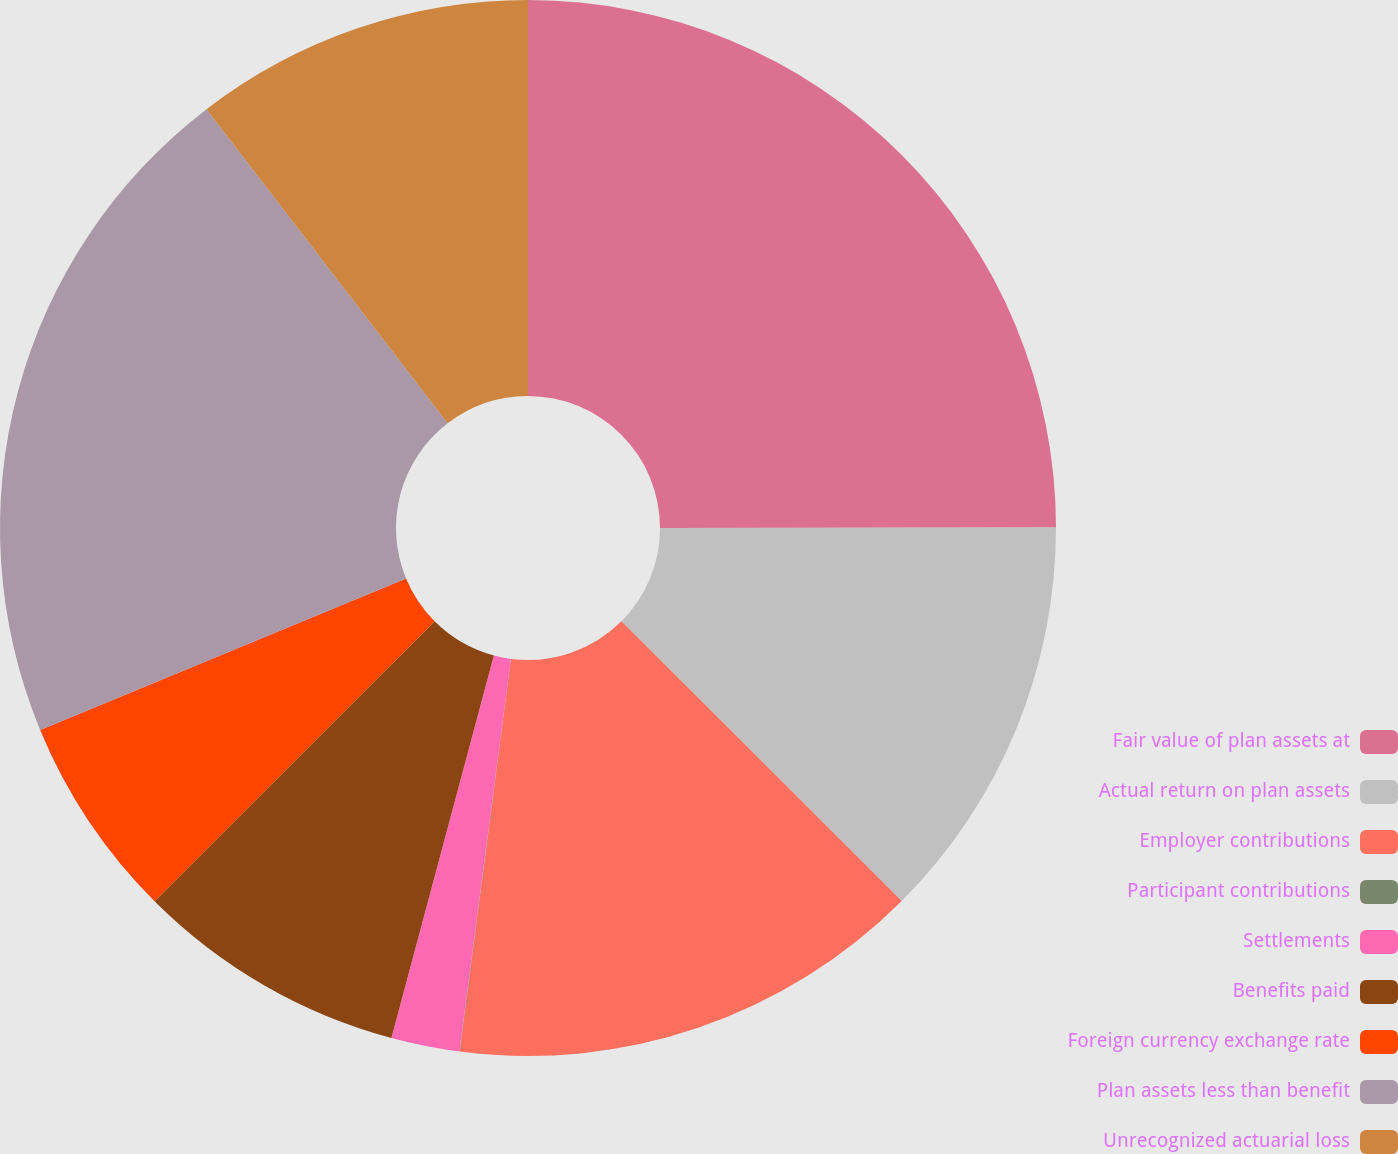Convert chart. <chart><loc_0><loc_0><loc_500><loc_500><pie_chart><fcel>Fair value of plan assets at<fcel>Actual return on plan assets<fcel>Employer contributions<fcel>Participant contributions<fcel>Settlements<fcel>Benefits paid<fcel>Foreign currency exchange rate<fcel>Plan assets less than benefit<fcel>Unrecognized actuarial loss<nl><fcel>24.99%<fcel>12.5%<fcel>14.58%<fcel>0.01%<fcel>2.09%<fcel>8.34%<fcel>6.25%<fcel>20.83%<fcel>10.42%<nl></chart> 